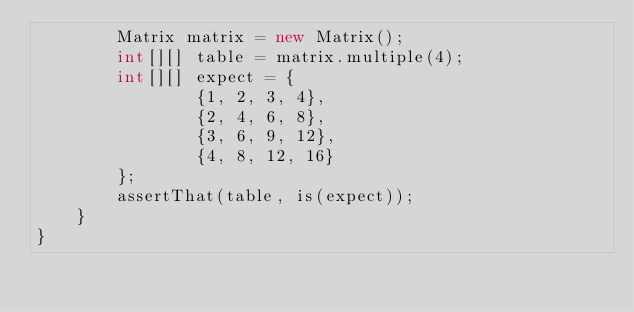Convert code to text. <code><loc_0><loc_0><loc_500><loc_500><_Java_>        Matrix matrix = new Matrix();
        int[][] table = matrix.multiple(4);
        int[][] expect = {
                {1, 2, 3, 4},
                {2, 4, 6, 8},
                {3, 6, 9, 12},
                {4, 8, 12, 16}
        };
        assertThat(table, is(expect));
    }
}</code> 